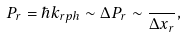<formula> <loc_0><loc_0><loc_500><loc_500>P _ { r } = \hbar { k } _ { r p h } \sim \Delta P _ { r } \sim \frac { } { \Delta x _ { r } } ,</formula> 